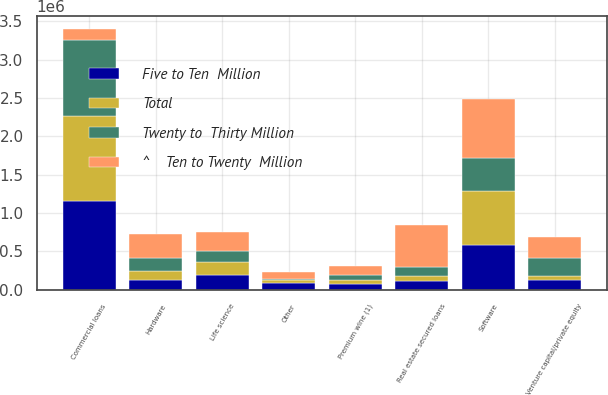Convert chart. <chart><loc_0><loc_0><loc_500><loc_500><stacked_bar_chart><ecel><fcel>Software<fcel>Hardware<fcel>Venture capital/private equity<fcel>Life science<fcel>Other<fcel>Commercial loans<fcel>Premium wine (1)<fcel>Real estate secured loans<nl><fcel>^    Ten to Twenty  Million<fcel>764200<fcel>306557<fcel>277087<fcel>251921<fcel>90110<fcel>140786<fcel>119708<fcel>554114<nl><fcel>Twenty to  Thirty Million<fcel>429670<fcel>166619<fcel>232775<fcel>140786<fcel>14915<fcel>998736<fcel>75161<fcel>116338<nl><fcel>Five to Ten  Million<fcel>578248<fcel>133505<fcel>127848<fcel>187874<fcel>82849<fcel>1.15309e+06<fcel>75247<fcel>114549<nl><fcel>Total<fcel>715772<fcel>116305<fcel>53000<fcel>171702<fcel>45435<fcel>1.10761e+06<fcel>45625<fcel>64557<nl></chart> 